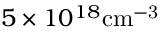<formula> <loc_0><loc_0><loc_500><loc_500>5 \times 1 0 ^ { 1 8 } c m ^ { - 3 }</formula> 